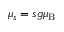<formula> <loc_0><loc_0><loc_500><loc_500>\mu _ { s } = s g { { \mu _ { B } } }</formula> 